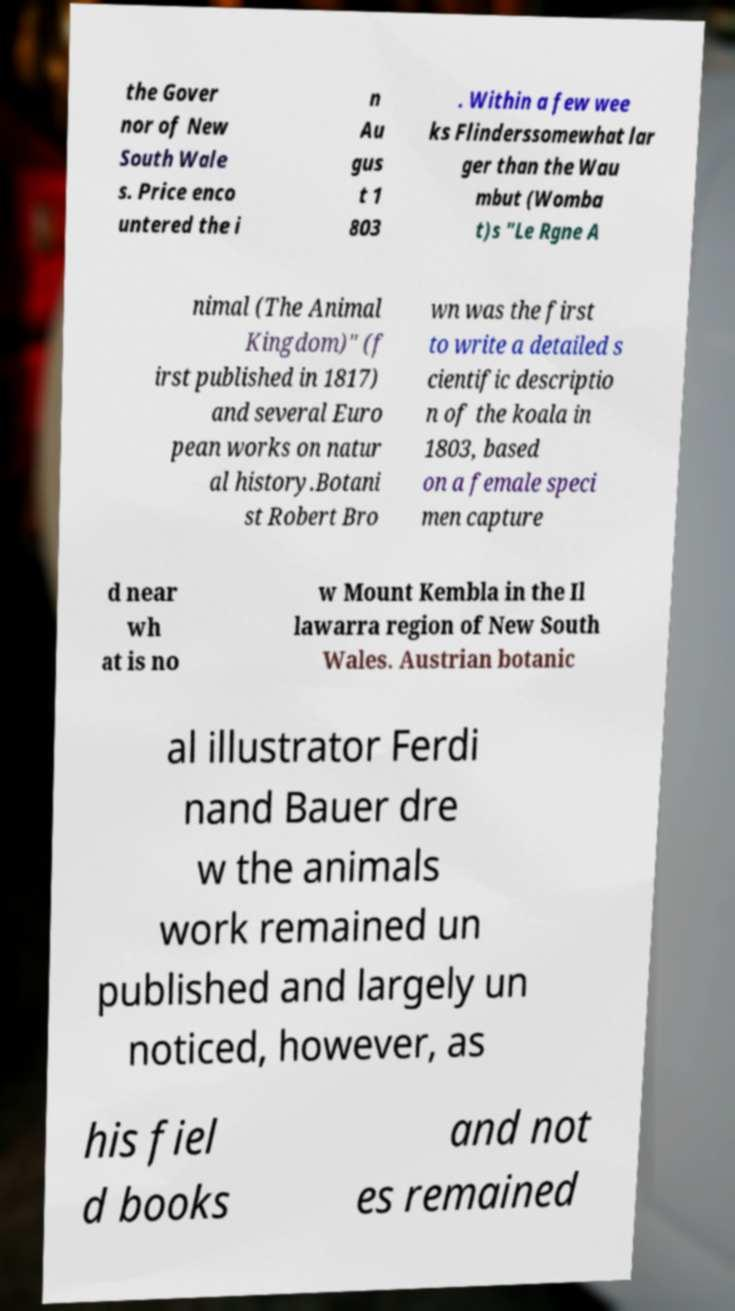There's text embedded in this image that I need extracted. Can you transcribe it verbatim? the Gover nor of New South Wale s. Price enco untered the i n Au gus t 1 803 . Within a few wee ks Flinderssomewhat lar ger than the Wau mbut (Womba t)s "Le Rgne A nimal (The Animal Kingdom)" (f irst published in 1817) and several Euro pean works on natur al history.Botani st Robert Bro wn was the first to write a detailed s cientific descriptio n of the koala in 1803, based on a female speci men capture d near wh at is no w Mount Kembla in the Il lawarra region of New South Wales. Austrian botanic al illustrator Ferdi nand Bauer dre w the animals work remained un published and largely un noticed, however, as his fiel d books and not es remained 